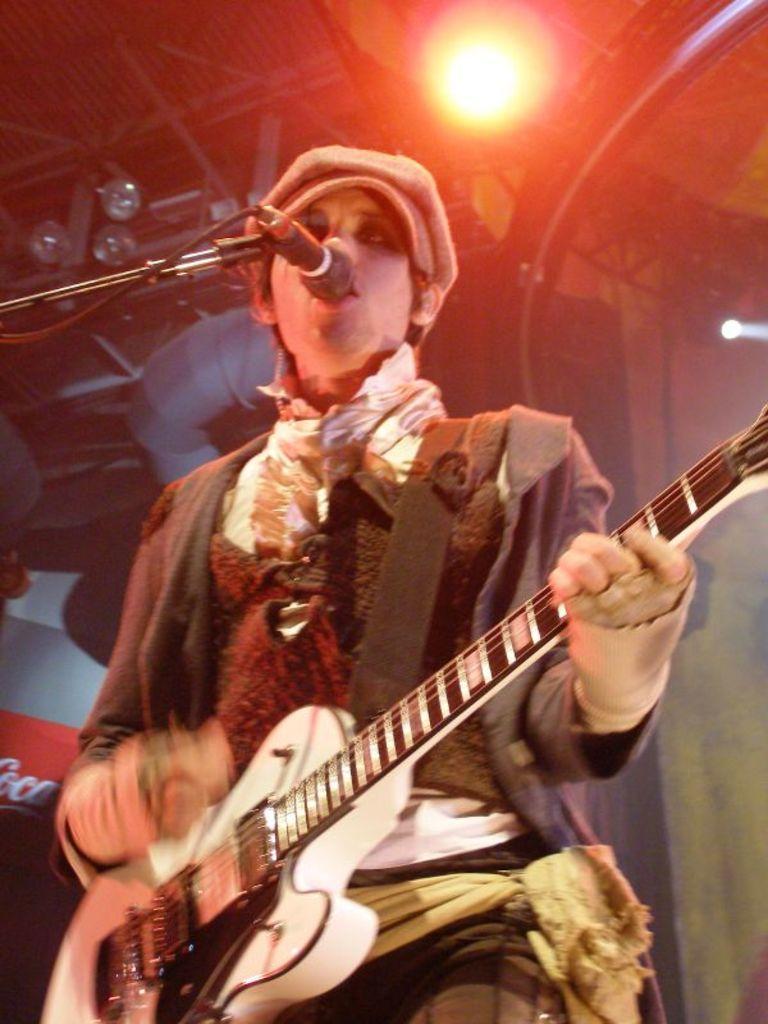Please provide a concise description of this image. In this picture we can see man holding guitar in his hand and playing and singing on mic and in background we can see light, wall. 